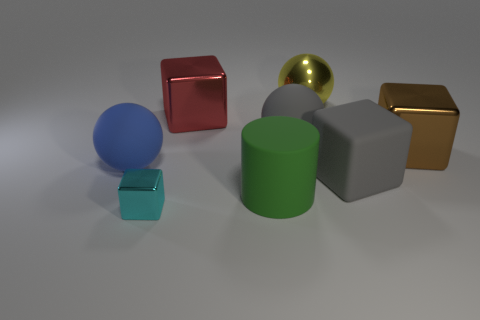What number of things are yellow metallic spheres that are right of the big blue ball or blocks on the left side of the yellow ball? In the image, there are no yellow metallic spheres to the right of the big blue ball, and since there is only one yellow metallic sphere, it cannot be to the left or right of itself. Therefore, the number of yellow metallic spheres that fit this description is zero. 